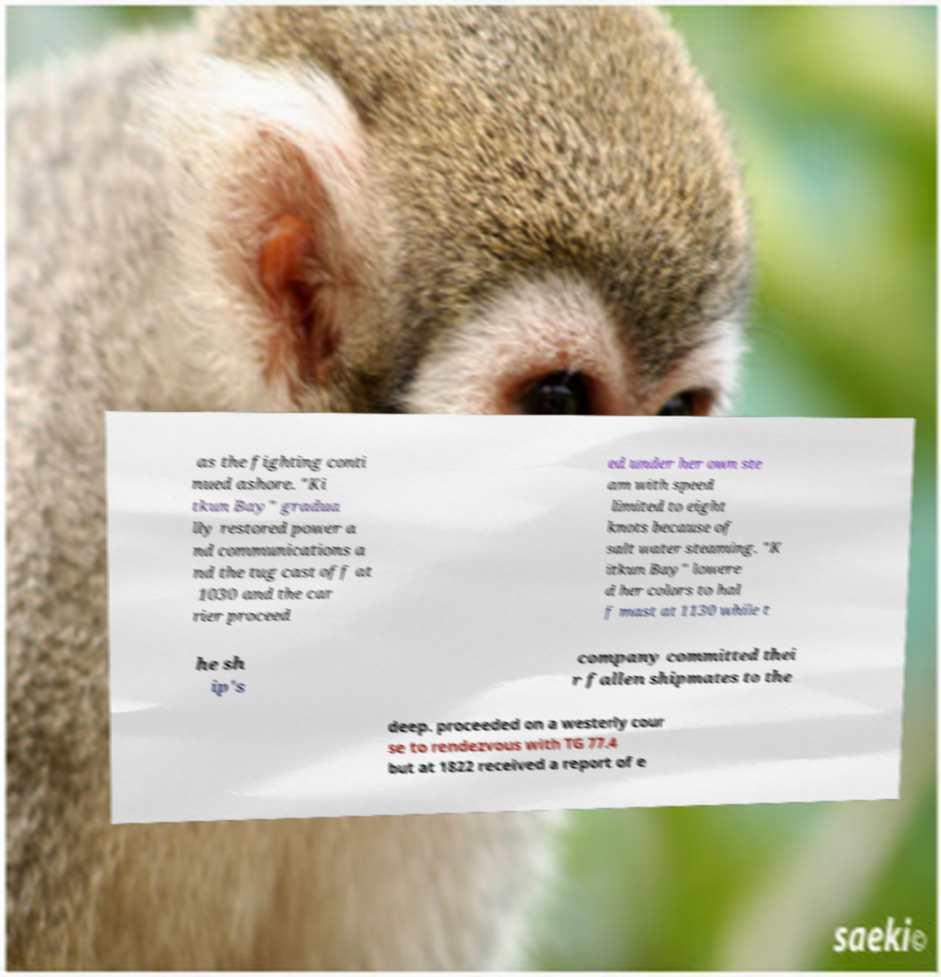There's text embedded in this image that I need extracted. Can you transcribe it verbatim? as the fighting conti nued ashore. "Ki tkun Bay" gradua lly restored power a nd communications a nd the tug cast off at 1030 and the car rier proceed ed under her own ste am with speed limited to eight knots because of salt water steaming. "K itkun Bay" lowere d her colors to hal f mast at 1130 while t he sh ip's company committed thei r fallen shipmates to the deep. proceeded on a westerly cour se to rendezvous with TG 77.4 but at 1822 received a report of e 